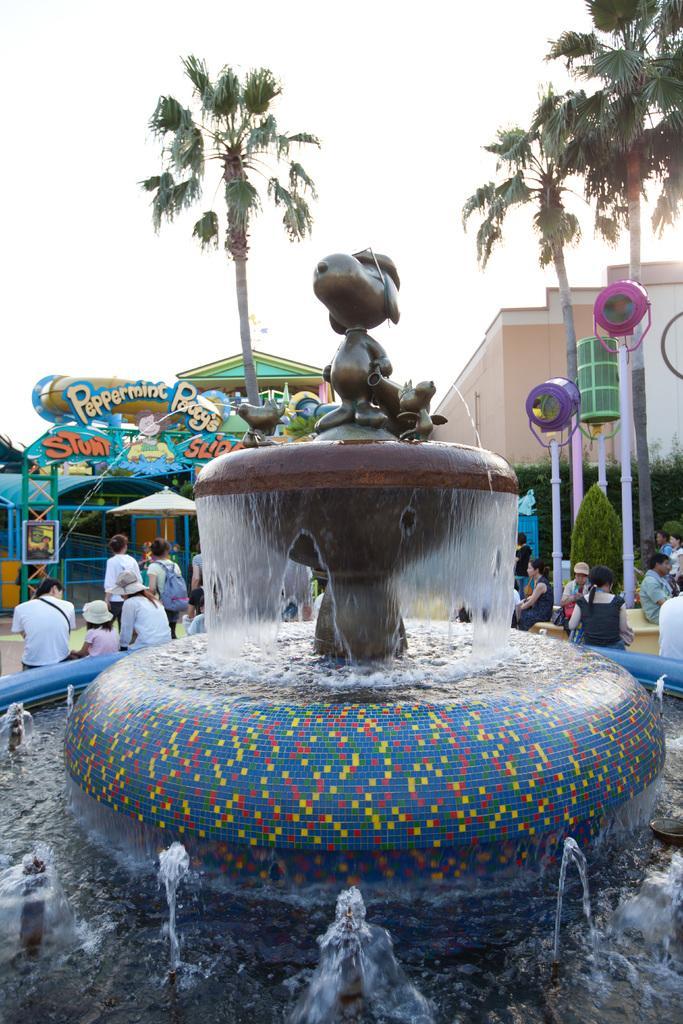Describe this image in one or two sentences. In this image, we can see some persons sitting beside the fountain. There is a building and trees on the right side of the image. There is a sky at the top of the image. 